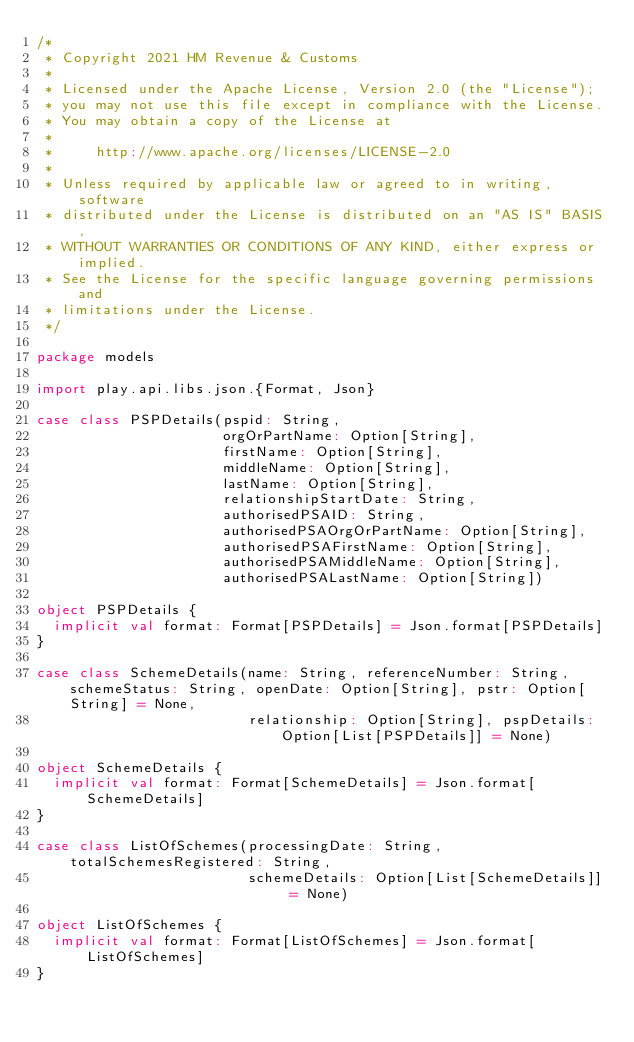<code> <loc_0><loc_0><loc_500><loc_500><_Scala_>/*
 * Copyright 2021 HM Revenue & Customs
 *
 * Licensed under the Apache License, Version 2.0 (the "License");
 * you may not use this file except in compliance with the License.
 * You may obtain a copy of the License at
 *
 *     http://www.apache.org/licenses/LICENSE-2.0
 *
 * Unless required by applicable law or agreed to in writing, software
 * distributed under the License is distributed on an "AS IS" BASIS,
 * WITHOUT WARRANTIES OR CONDITIONS OF ANY KIND, either express or implied.
 * See the License for the specific language governing permissions and
 * limitations under the License.
 */

package models

import play.api.libs.json.{Format, Json}

case class PSPDetails(pspid: String,
                      orgOrPartName: Option[String],
                      firstName: Option[String],
                      middleName: Option[String],
                      lastName: Option[String],
                      relationshipStartDate: String,
                      authorisedPSAID: String,
                      authorisedPSAOrgOrPartName: Option[String],
                      authorisedPSAFirstName: Option[String],
                      authorisedPSAMiddleName: Option[String],
                      authorisedPSALastName: Option[String])

object PSPDetails {
  implicit val format: Format[PSPDetails] = Json.format[PSPDetails]
}

case class SchemeDetails(name: String, referenceNumber: String, schemeStatus: String, openDate: Option[String], pstr: Option[String] = None,
                         relationship: Option[String], pspDetails: Option[List[PSPDetails]] = None)

object SchemeDetails {
  implicit val format: Format[SchemeDetails] = Json.format[SchemeDetails]
}

case class ListOfSchemes(processingDate: String, totalSchemesRegistered: String,
                         schemeDetails: Option[List[SchemeDetails]] = None)

object ListOfSchemes {
  implicit val format: Format[ListOfSchemes] = Json.format[ListOfSchemes]
}
</code> 